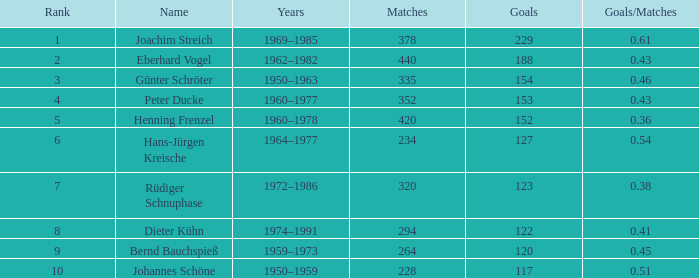What years have goals less than 229, and 440 as matches? 1962–1982. Would you mind parsing the complete table? {'header': ['Rank', 'Name', 'Years', 'Matches', 'Goals', 'Goals/Matches'], 'rows': [['1', 'Joachim Streich', '1969–1985', '378', '229', '0.61'], ['2', 'Eberhard Vogel', '1962–1982', '440', '188', '0.43'], ['3', 'Günter Schröter', '1950–1963', '335', '154', '0.46'], ['4', 'Peter Ducke', '1960–1977', '352', '153', '0.43'], ['5', 'Henning Frenzel', '1960–1978', '420', '152', '0.36'], ['6', 'Hans-Jürgen Kreische', '1964–1977', '234', '127', '0.54'], ['7', 'Rüdiger Schnuphase', '1972–1986', '320', '123', '0.38'], ['8', 'Dieter Kühn', '1974–1991', '294', '122', '0.41'], ['9', 'Bernd Bauchspieß', '1959–1973', '264', '120', '0.45'], ['10', 'Johannes Schöne', '1950–1959', '228', '117', '0.51']]} 